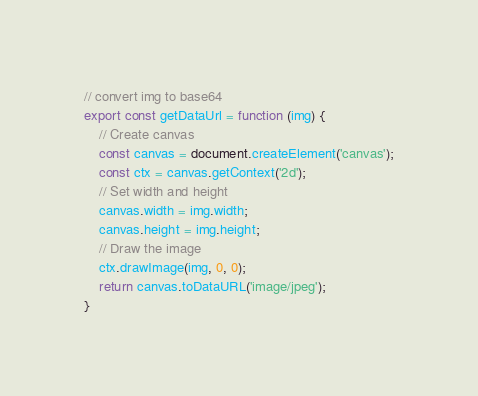Convert code to text. <code><loc_0><loc_0><loc_500><loc_500><_JavaScript_>// convert img to base64
export const getDataUrl = function (img) {
    // Create canvas
    const canvas = document.createElement('canvas');
    const ctx = canvas.getContext('2d');
    // Set width and height
    canvas.width = img.width;
    canvas.height = img.height;
    // Draw the image
    ctx.drawImage(img, 0, 0);
    return canvas.toDataURL('image/jpeg');
}</code> 